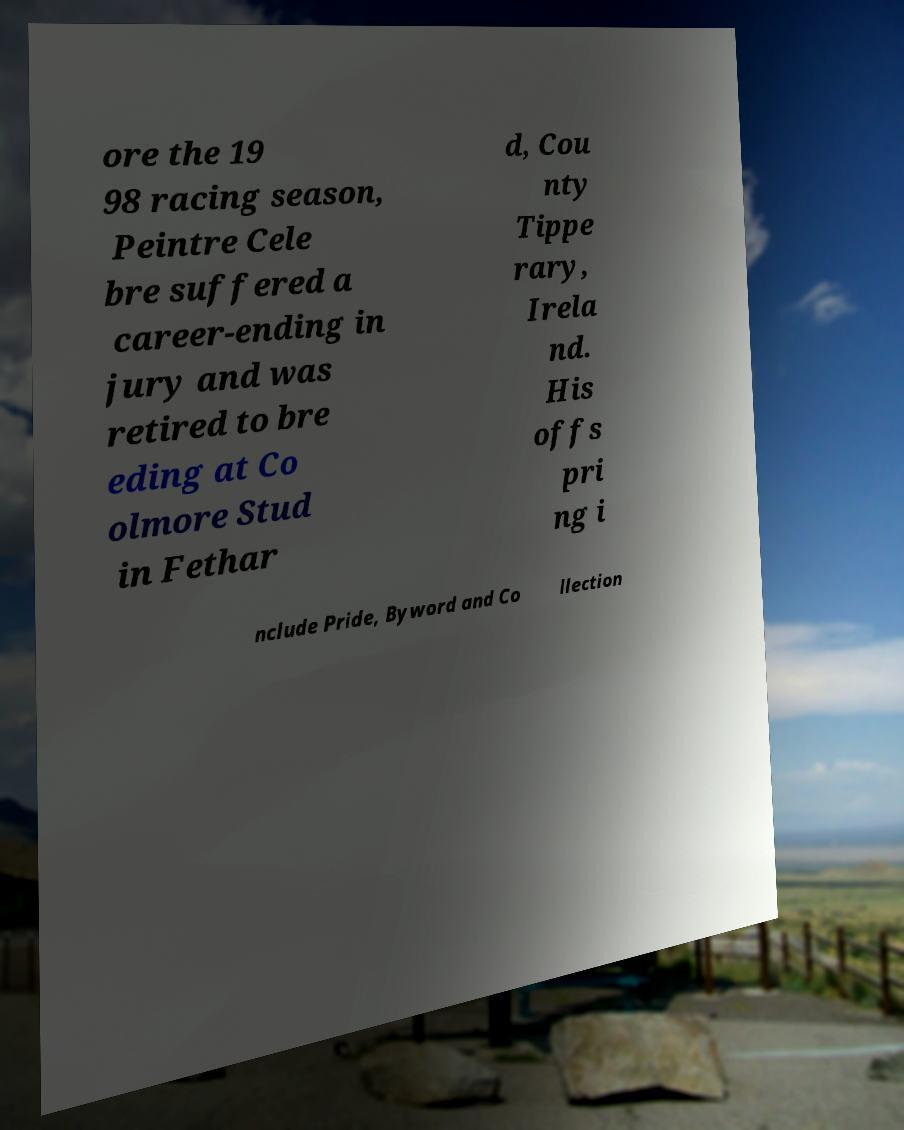Could you extract and type out the text from this image? ore the 19 98 racing season, Peintre Cele bre suffered a career-ending in jury and was retired to bre eding at Co olmore Stud in Fethar d, Cou nty Tippe rary, Irela nd. His offs pri ng i nclude Pride, Byword and Co llection 